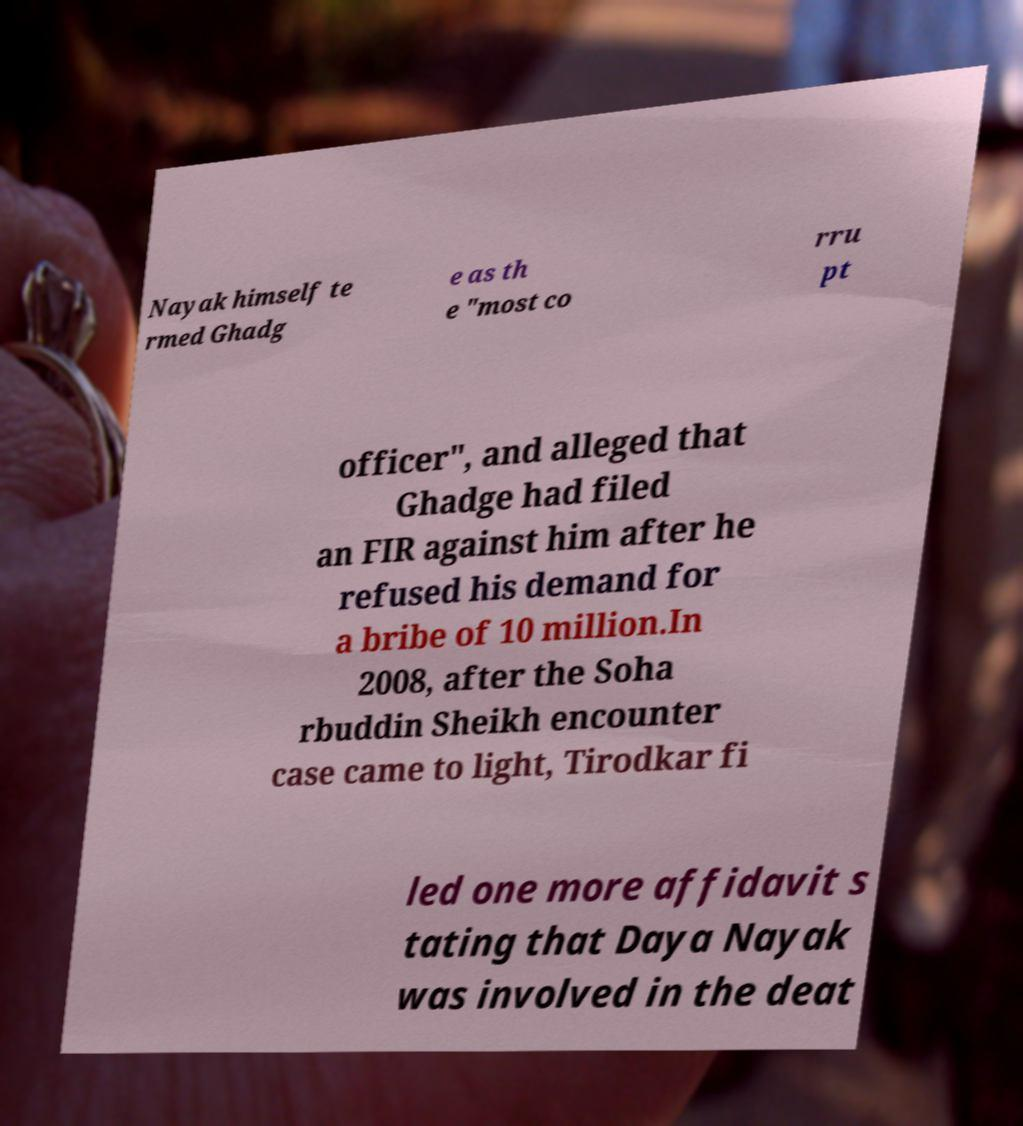Can you accurately transcribe the text from the provided image for me? Nayak himself te rmed Ghadg e as th e "most co rru pt officer", and alleged that Ghadge had filed an FIR against him after he refused his demand for a bribe of 10 million.In 2008, after the Soha rbuddin Sheikh encounter case came to light, Tirodkar fi led one more affidavit s tating that Daya Nayak was involved in the deat 